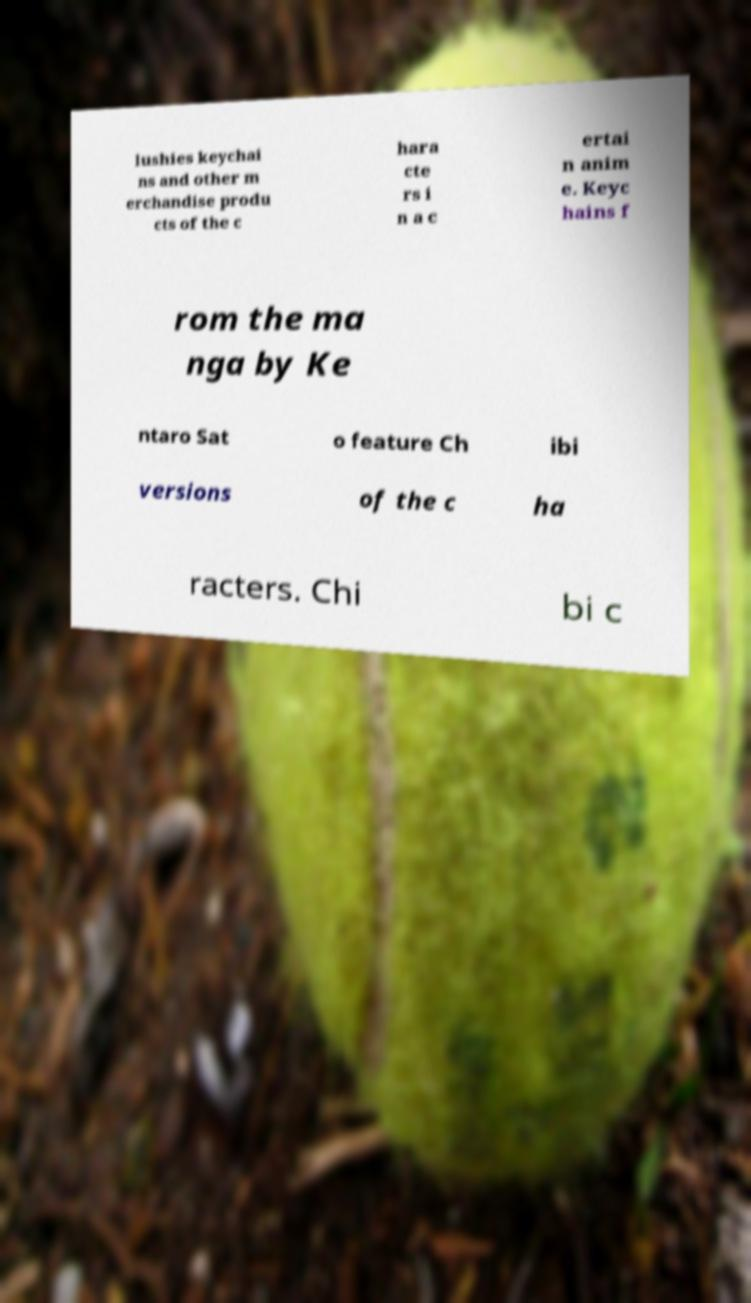Could you extract and type out the text from this image? lushies keychai ns and other m erchandise produ cts of the c hara cte rs i n a c ertai n anim e. Keyc hains f rom the ma nga by Ke ntaro Sat o feature Ch ibi versions of the c ha racters. Chi bi c 